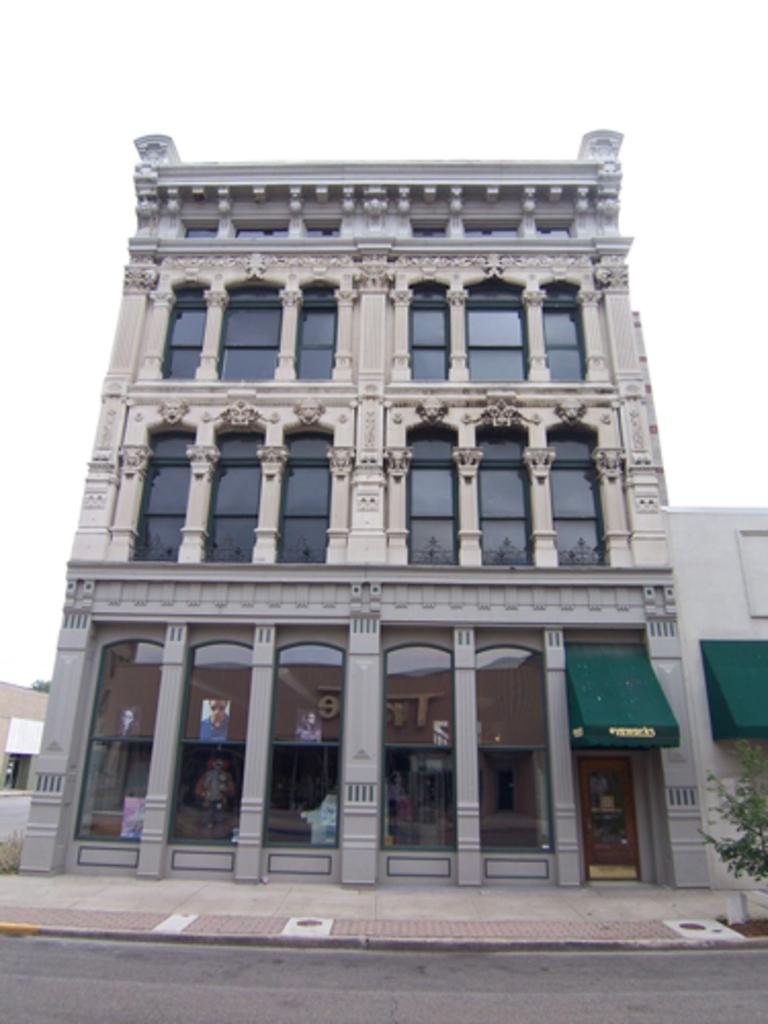What type of structures are present in the image? There are buildings in the image. What features can be observed on the buildings? The buildings have windows and pillars. What else can be seen in the image besides the buildings? There are posters, trees, and a board with text in the image. What is visible in the background of the image? The sky is visible in the image. How many legs does the belief have in the image? There is no belief present in the image, and therefore no legs can be attributed to it. 